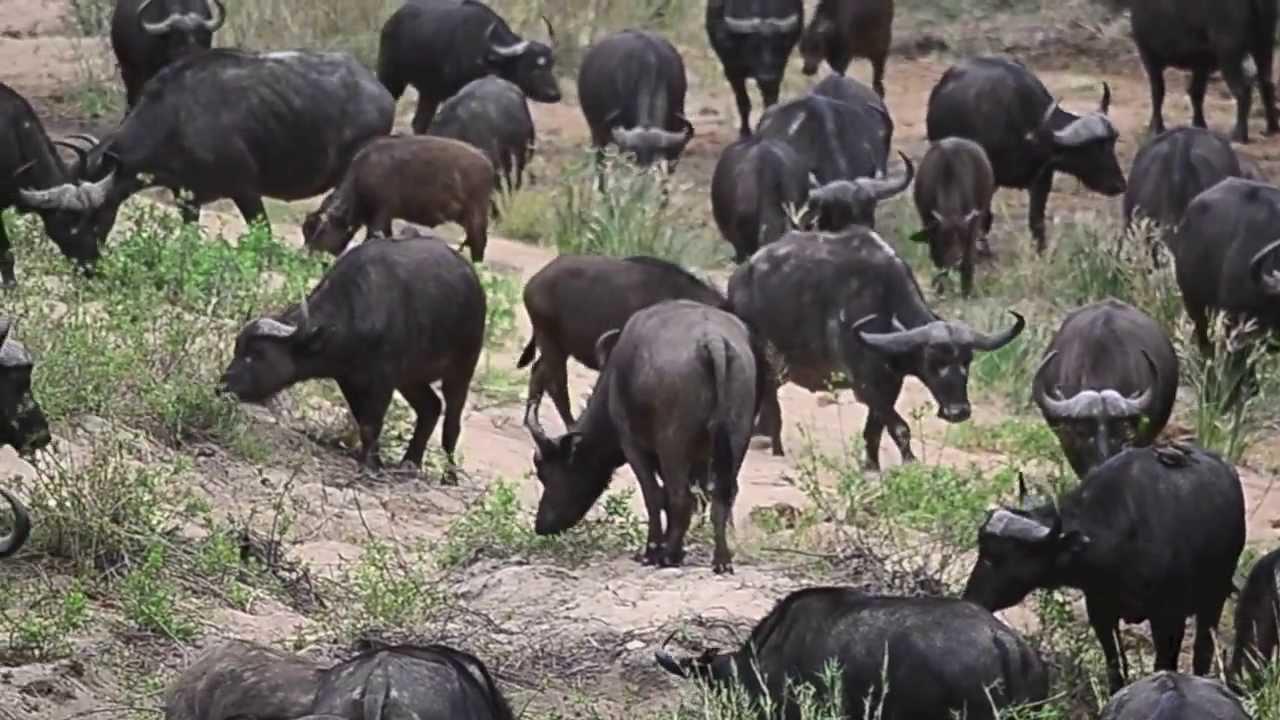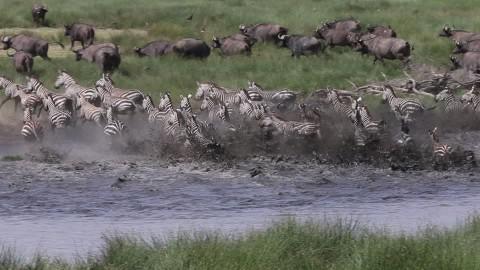The first image is the image on the left, the second image is the image on the right. Assess this claim about the two images: "The left image shows a fog-like cloud above a herd of dark hooved animals moving en masse.". Correct or not? Answer yes or no. No. The first image is the image on the left, the second image is the image on the right. Assess this claim about the two images: "Several water buffalos are standing in water in one of the images.". Correct or not? Answer yes or no. No. 